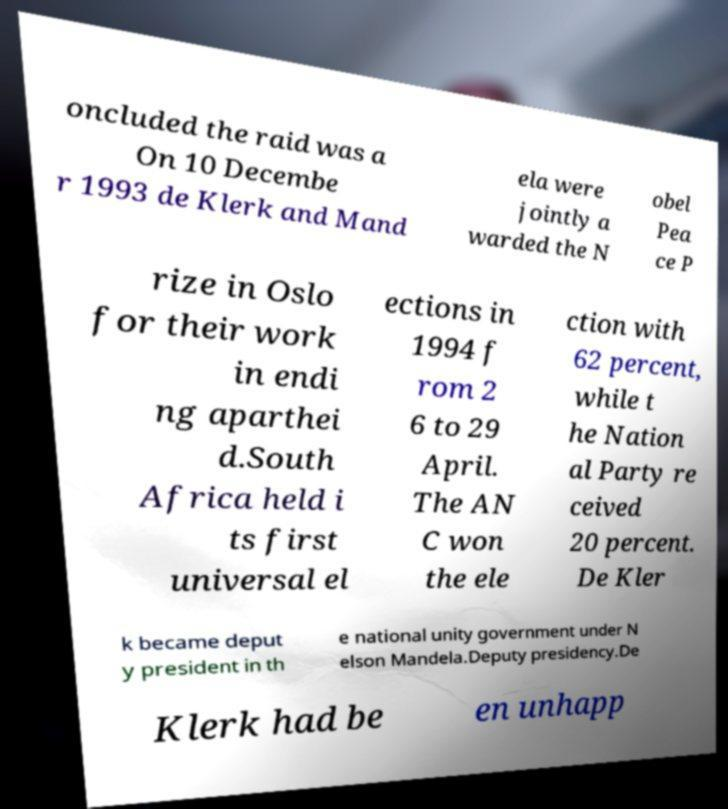Please read and relay the text visible in this image. What does it say? oncluded the raid was a On 10 Decembe r 1993 de Klerk and Mand ela were jointly a warded the N obel Pea ce P rize in Oslo for their work in endi ng aparthei d.South Africa held i ts first universal el ections in 1994 f rom 2 6 to 29 April. The AN C won the ele ction with 62 percent, while t he Nation al Party re ceived 20 percent. De Kler k became deput y president in th e national unity government under N elson Mandela.Deputy presidency.De Klerk had be en unhapp 